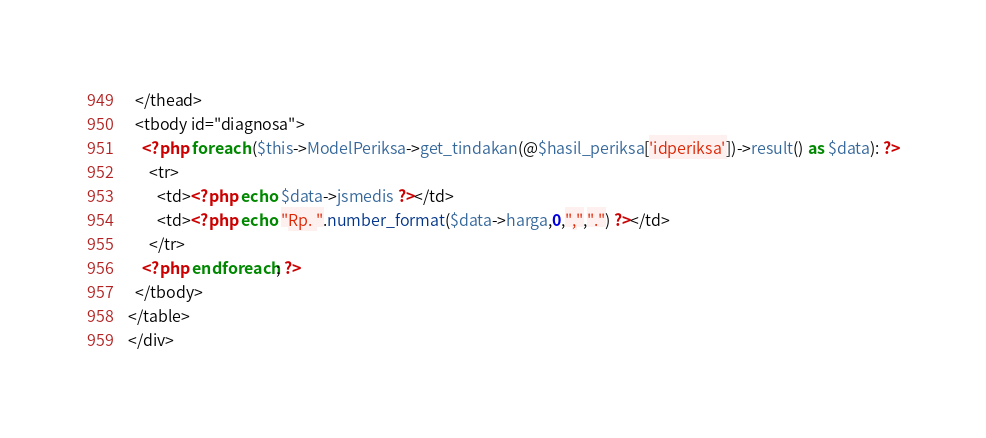Convert code to text. <code><loc_0><loc_0><loc_500><loc_500><_PHP_>  </thead>
  <tbody id="diagnosa">
    <?php foreach ($this->ModelPeriksa->get_tindakan(@$hasil_periksa['idperiksa'])->result() as $data): ?>
      <tr>
        <td><?php echo $data->jsmedis ?></td>
        <td><?php echo "Rp. ".number_format($data->harga,0,",",".") ?></td>
      </tr>
    <?php endforeach; ?>
  </tbody>
</table>
</div>
</code> 